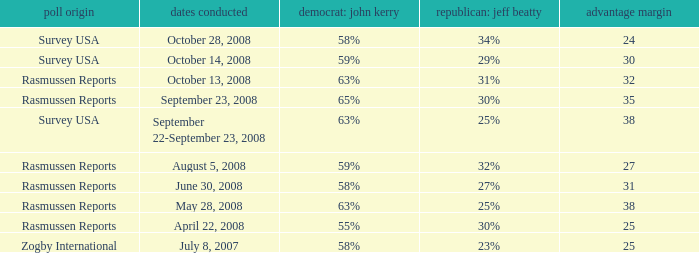What percent is the lead margin of 25 that Republican: Jeff Beatty has according to poll source Rasmussen Reports? 30%. 